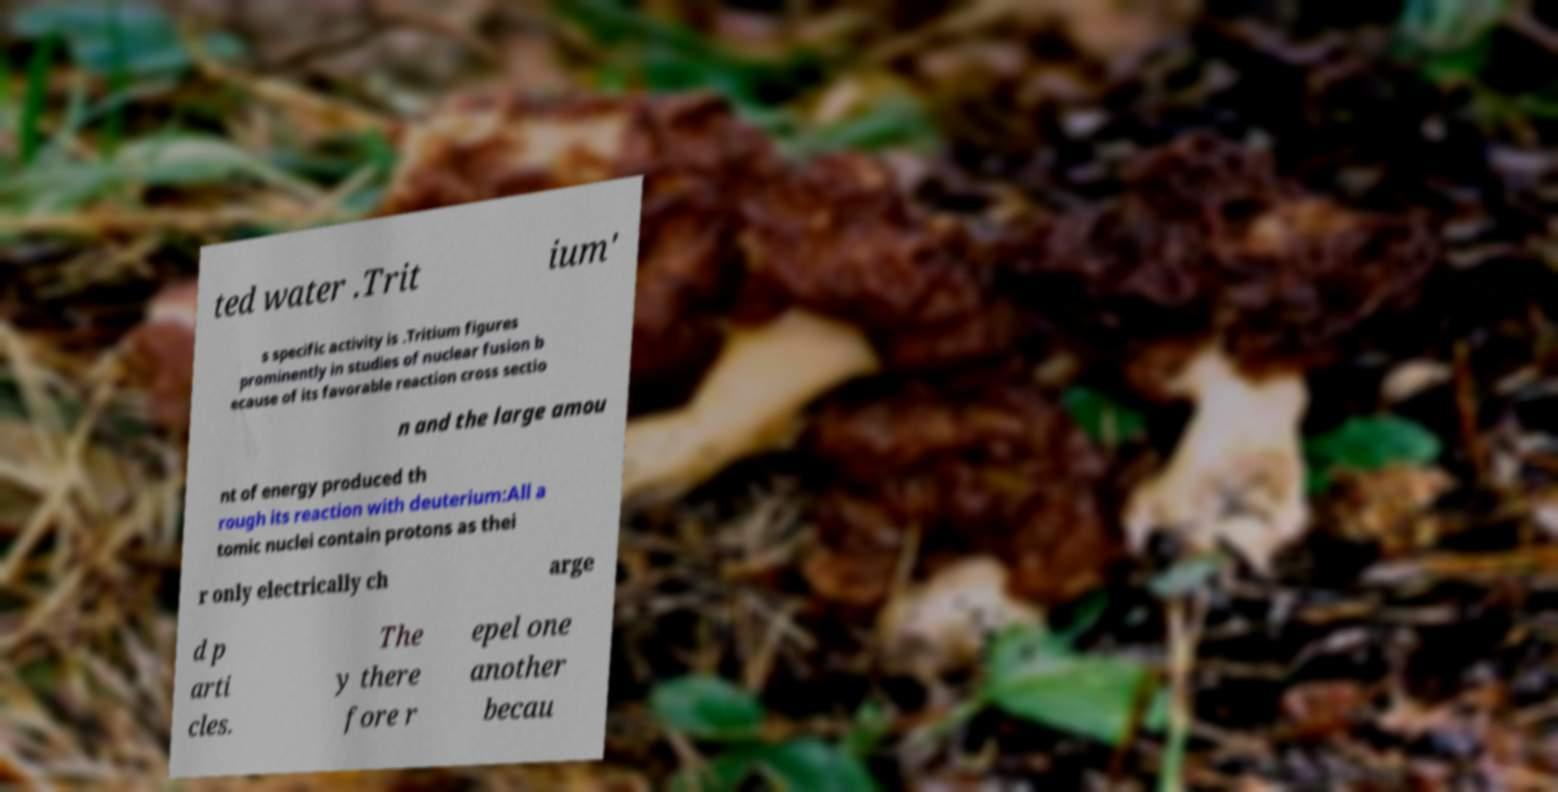Can you read and provide the text displayed in the image?This photo seems to have some interesting text. Can you extract and type it out for me? ted water .Trit ium' s specific activity is .Tritium figures prominently in studies of nuclear fusion b ecause of its favorable reaction cross sectio n and the large amou nt of energy produced th rough its reaction with deuterium:All a tomic nuclei contain protons as thei r only electrically ch arge d p arti cles. The y there fore r epel one another becau 